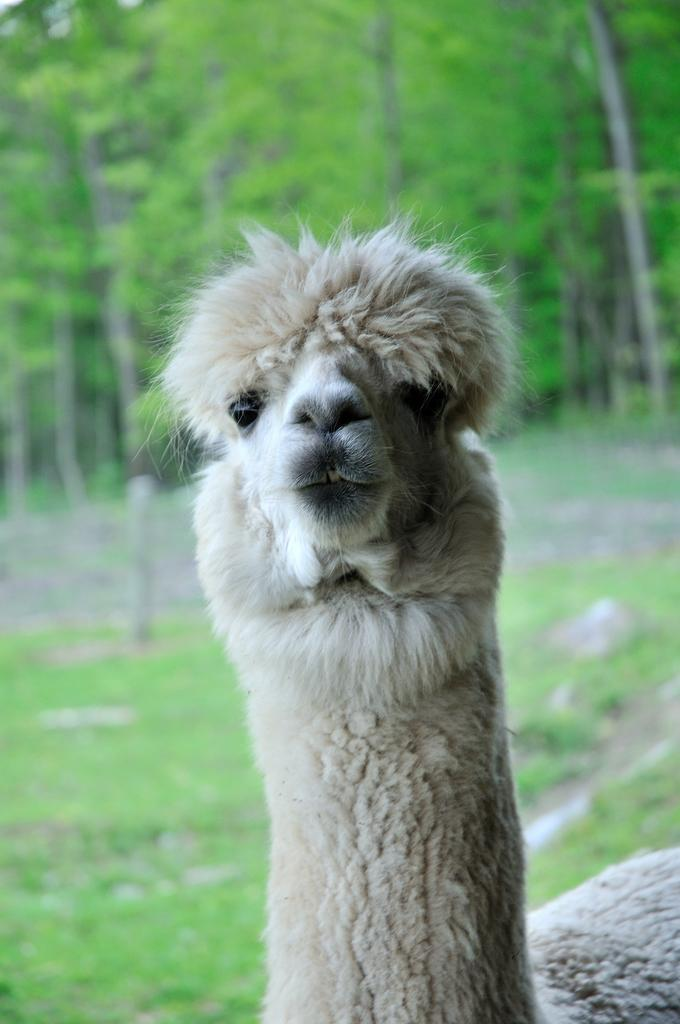What type of animal is in the image? The specific type of animal cannot be determined from the provided facts. What can be seen in the image besides the animal? There are trees visible in the image. How would you describe the background of the image? The background of the image is blurred. How does the animal control the mark on the tree in the image? There is no indication in the image that the animal is controlling a mark on the tree, nor is there any visible mark on the tree. 